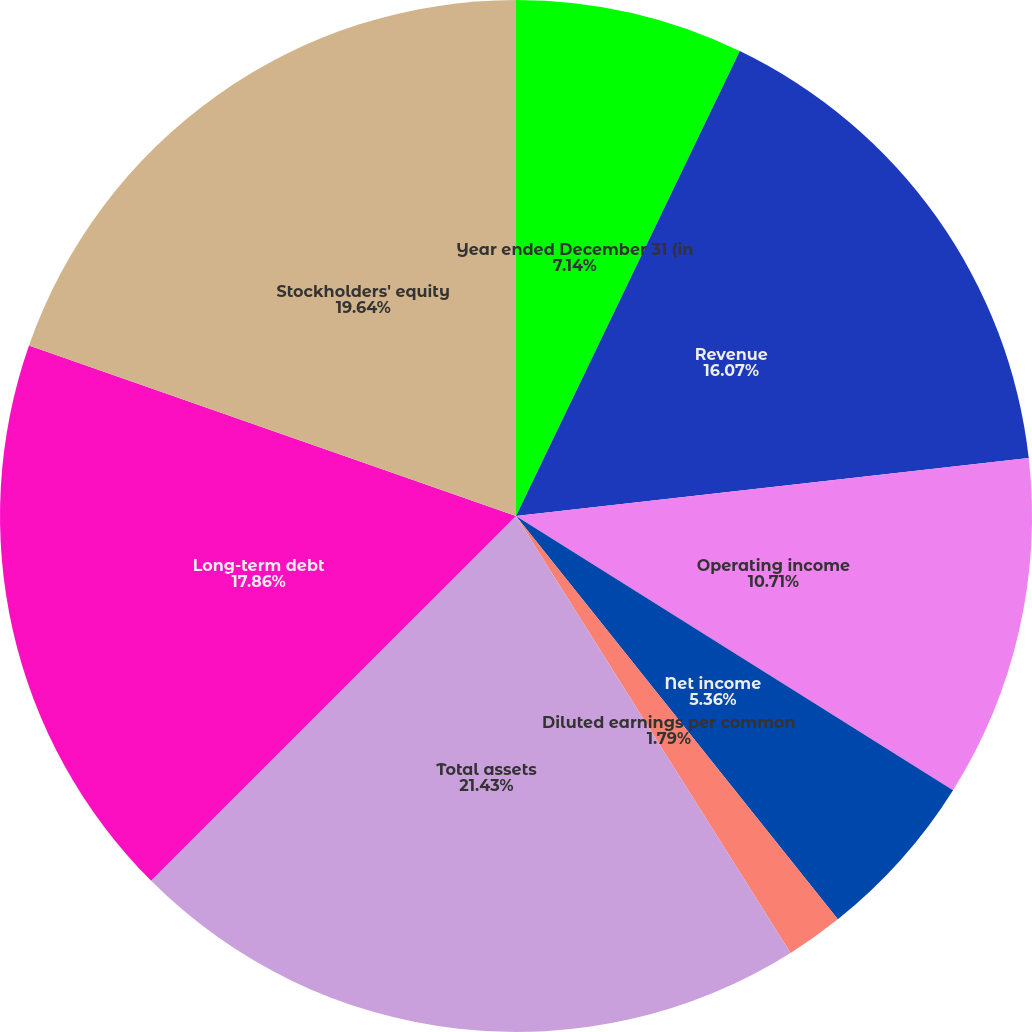Convert chart. <chart><loc_0><loc_0><loc_500><loc_500><pie_chart><fcel>Year ended December 31 (in<fcel>Revenue<fcel>Operating income<fcel>Income from continuing<fcel>Net income<fcel>Diluted earnings per common<fcel>Total assets<fcel>Long-term debt<fcel>Stockholders' equity<nl><fcel>7.14%<fcel>16.07%<fcel>10.71%<fcel>0.0%<fcel>5.36%<fcel>1.79%<fcel>21.43%<fcel>17.86%<fcel>19.64%<nl></chart> 